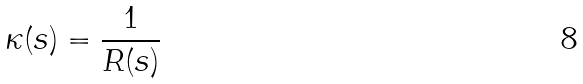Convert formula to latex. <formula><loc_0><loc_0><loc_500><loc_500>\kappa ( s ) = \frac { 1 } { R ( s ) }</formula> 